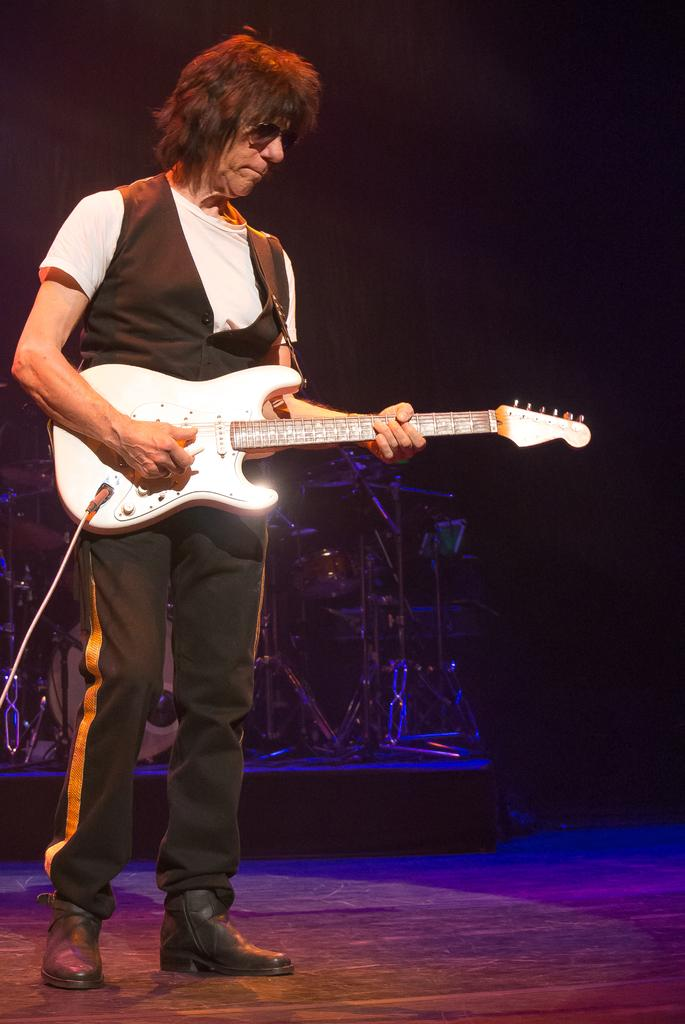Who is the main subject in the image? There is a man in the image. What is the man doing in the image? The man is standing and playing the guitar. Where is the man located in the image? The man is on a stage. What other musical instrument can be seen in the image? There are drums visible in the image. What type of stick is the man using to play the guitar in the image? The man is not using a stick to play the guitar in the image; he is using his hands. 